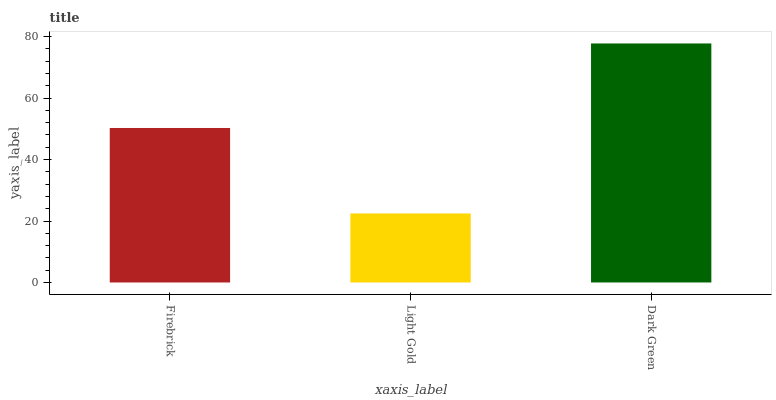Is Light Gold the minimum?
Answer yes or no. Yes. Is Dark Green the maximum?
Answer yes or no. Yes. Is Dark Green the minimum?
Answer yes or no. No. Is Light Gold the maximum?
Answer yes or no. No. Is Dark Green greater than Light Gold?
Answer yes or no. Yes. Is Light Gold less than Dark Green?
Answer yes or no. Yes. Is Light Gold greater than Dark Green?
Answer yes or no. No. Is Dark Green less than Light Gold?
Answer yes or no. No. Is Firebrick the high median?
Answer yes or no. Yes. Is Firebrick the low median?
Answer yes or no. Yes. Is Light Gold the high median?
Answer yes or no. No. Is Light Gold the low median?
Answer yes or no. No. 